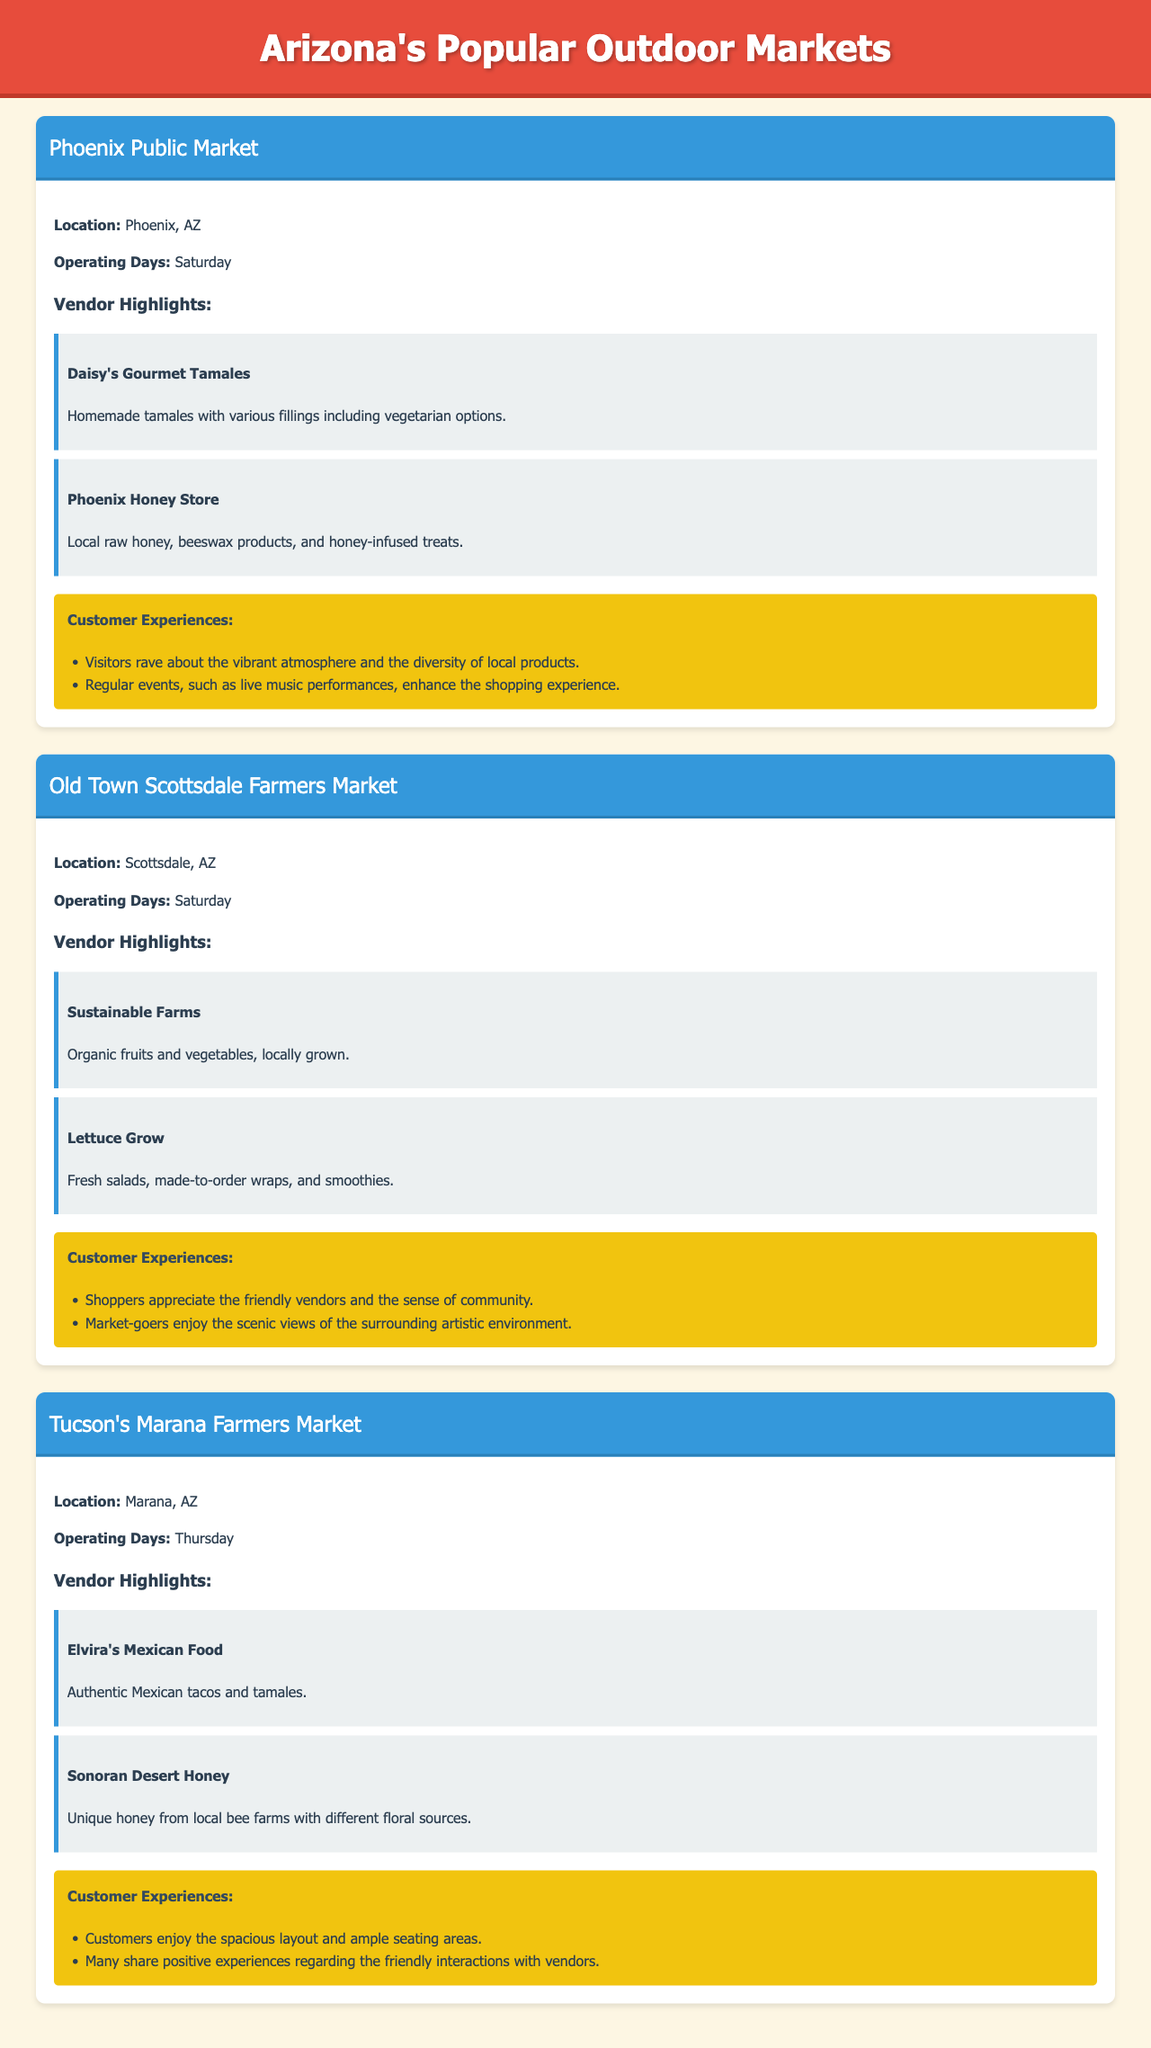What is the location of the Phoenix Public Market? The document specifies the location of the Phoenix Public Market as Phoenix, AZ.
Answer: Phoenix, AZ How many vendors are highlighted for Tucson's Marana Farmers Market? The document lists two vendor highlights for Tucson's Marana Farmers Market.
Answer: 2 What day does the Old Town Scottsdale Farmers Market operate? According to the document, the Old Town Scottsdale Farmers Market operates on Saturday.
Answer: Saturday What type of cuisine does Elvira's Mexican Food offer? The document describes Elvira's Mexican Food as offering authentic Mexican tacos and tamales.
Answer: Authentic Mexican tacos and tamales Which market features local raw honey products? The document indicates that the Phoenix Honey Store at the Phoenix Public Market features local raw honey products.
Answer: Phoenix Public Market What do shoppers appreciate about the vendors at the Old Town Scottsdale Farmers Market? The document notes that shoppers appreciate the friendly vendors at the Old Town Scottsdale Farmers Market.
Answer: Friendly vendors What is a unique feature of Tucson's Marana Farmers Market? The document states that Tucson's Marana Farmers Market has a spacious layout and ample seating areas, which is a unique feature.
Answer: Spacious layout and ample seating areas What is one reason visitors enjoy the Phoenix Public Market? The document mentions that visitors rave about the vibrant atmosphere at the Phoenix Public Market.
Answer: Vibrant atmosphere What kind of products does Sustainable Farms sell? The document highlights that Sustainable Farms sells organic fruits and vegetables, locally grown.
Answer: Organic fruits and vegetables 